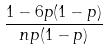Convert formula to latex. <formula><loc_0><loc_0><loc_500><loc_500>\frac { 1 - 6 p ( 1 - p ) } { n p ( 1 - p ) }</formula> 